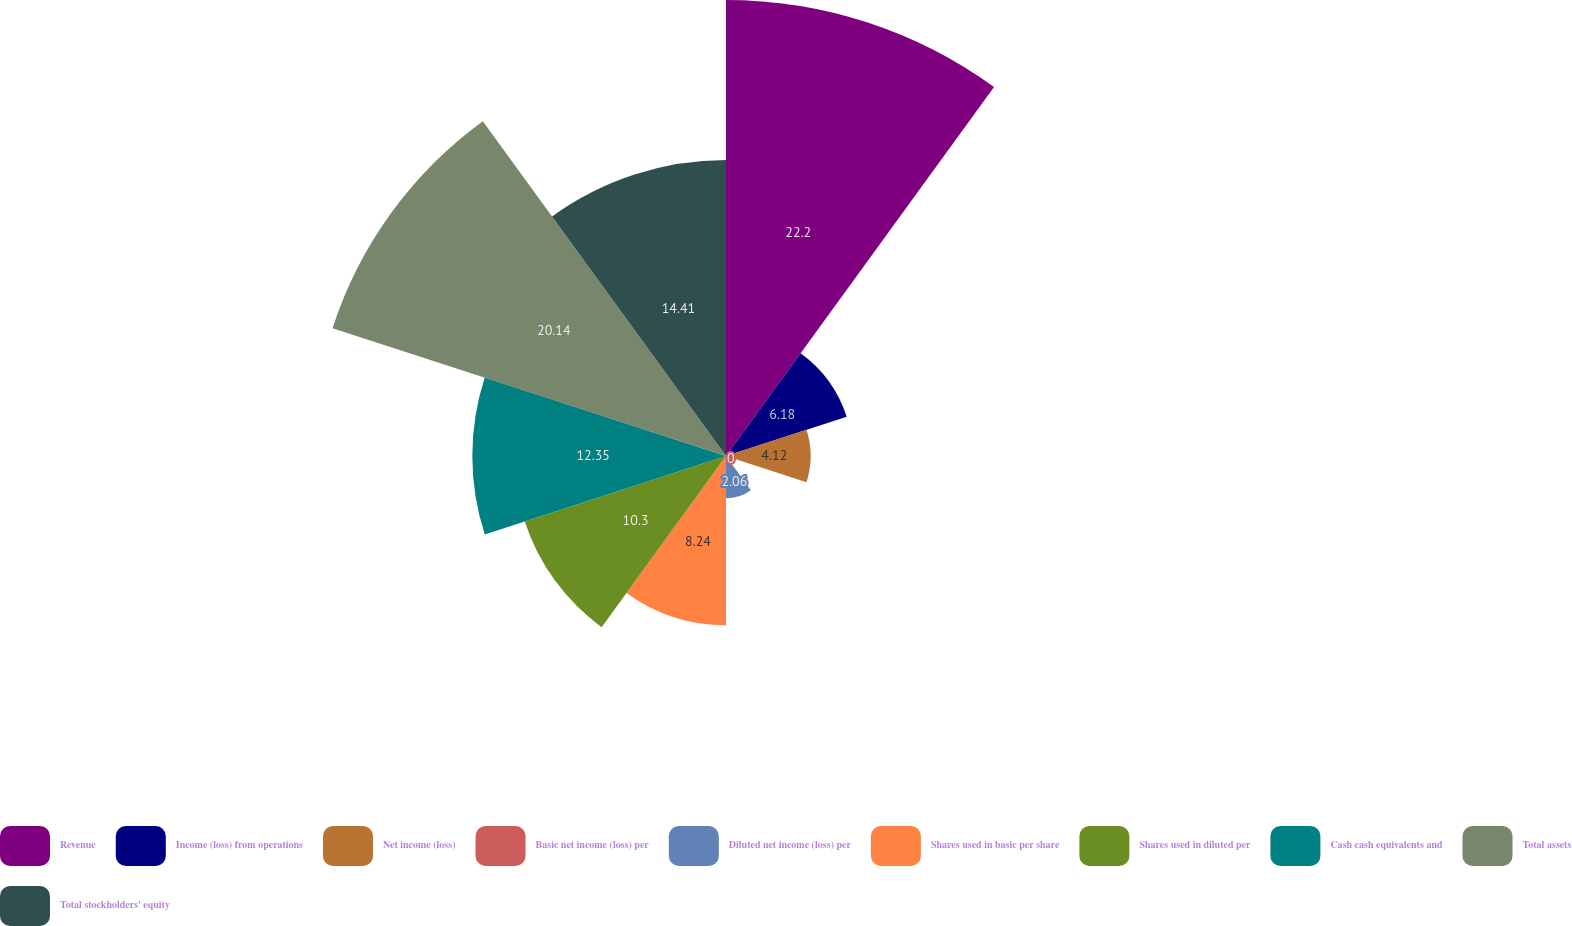Convert chart to OTSL. <chart><loc_0><loc_0><loc_500><loc_500><pie_chart><fcel>Revenue<fcel>Income (loss) from operations<fcel>Net income (loss)<fcel>Basic net income (loss) per<fcel>Diluted net income (loss) per<fcel>Shares used in basic per share<fcel>Shares used in diluted per<fcel>Cash cash equivalents and<fcel>Total assets<fcel>Total stockholders' equity<nl><fcel>22.2%<fcel>6.18%<fcel>4.12%<fcel>0.0%<fcel>2.06%<fcel>8.24%<fcel>10.3%<fcel>12.35%<fcel>20.14%<fcel>14.41%<nl></chart> 